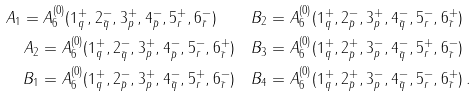Convert formula to latex. <formula><loc_0><loc_0><loc_500><loc_500>A _ { 1 } = A _ { 6 } ^ { ( 0 ) } ( 1 _ { q } ^ { + } , 2 _ { \bar { q } } ^ { - } , 3 _ { p } ^ { + } , 4 _ { \bar { p } } ^ { - } , 5 _ { r } ^ { + } , 6 _ { \bar { r } } ^ { - } ) \quad & B _ { 2 } = A _ { 6 } ^ { ( 0 ) } ( 1 _ { q } ^ { + } , 2 _ { \bar { p } } ^ { - } , 3 _ { p } ^ { + } , 4 _ { \bar { q } } ^ { - } , 5 _ { r } ^ { - } , 6 _ { \bar { r } } ^ { + } ) \\ A _ { 2 } = A _ { 6 } ^ { ( 0 ) } ( 1 _ { q } ^ { + } , 2 _ { \bar { q } } ^ { - } , 3 _ { p } ^ { + } , 4 _ { \bar { p } } ^ { - } , 5 _ { r } ^ { - } , 6 _ { \bar { r } } ^ { + } ) \quad & B _ { 3 } = A _ { 6 } ^ { ( 0 ) } ( 1 _ { q } ^ { + } , 2 _ { \bar { p } } ^ { + } , 3 _ { p } ^ { - } , 4 _ { \bar { q } } ^ { - } , 5 _ { r } ^ { + } , 6 _ { \bar { r } } ^ { - } ) \\ B _ { 1 } = A _ { 6 } ^ { ( 0 ) } ( 1 _ { q } ^ { + } , 2 _ { \bar { p } } ^ { - } , 3 _ { p } ^ { + } , 4 _ { \bar { q } } ^ { - } , 5 _ { r } ^ { + } , 6 _ { \bar { r } } ^ { - } ) \quad & B _ { 4 } = A _ { 6 } ^ { ( 0 ) } ( 1 _ { q } ^ { + } , 2 _ { \bar { p } } ^ { + } , 3 _ { p } ^ { - } , 4 _ { \bar { q } } ^ { - } , 5 _ { r } ^ { - } , 6 _ { \bar { r } } ^ { + } ) \, .</formula> 